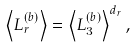Convert formula to latex. <formula><loc_0><loc_0><loc_500><loc_500>\left \langle L _ { r } ^ { ( b ) } \right \rangle = \left \langle L _ { 3 } ^ { ( b ) } \right \rangle ^ { d _ { r } } ,</formula> 